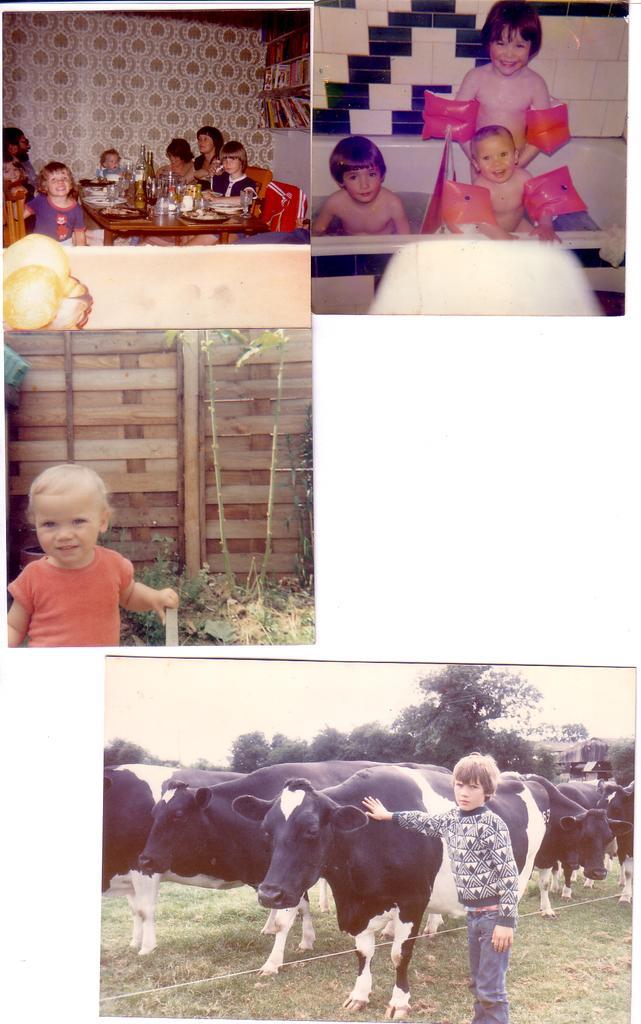Could you give a brief overview of what you see in this image? This is a collage image. At the bottom of the image we can see a boy is standing and also we can see the buffaloes, trees, ground. On the left side of the image we can see a kid, wall, ground. At the top of the image we can see a table, beside a table some persons are sitting on the chairs and also we can see the wall. And we can see three person, table, wall. 